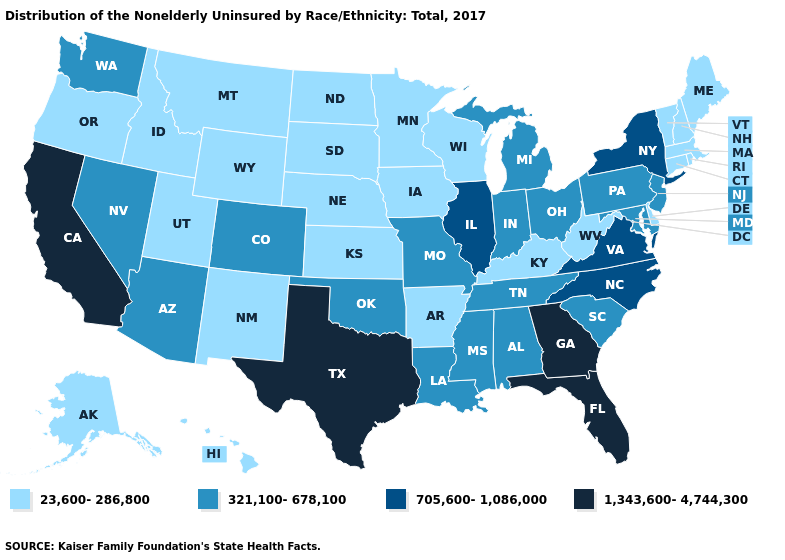What is the value of Louisiana?
Give a very brief answer. 321,100-678,100. Name the states that have a value in the range 705,600-1,086,000?
Answer briefly. Illinois, New York, North Carolina, Virginia. What is the value of Massachusetts?
Write a very short answer. 23,600-286,800. What is the value of Kentucky?
Short answer required. 23,600-286,800. Does Tennessee have a lower value than Georgia?
Quick response, please. Yes. Among the states that border Texas , which have the highest value?
Quick response, please. Louisiana, Oklahoma. Among the states that border Idaho , does Washington have the highest value?
Keep it brief. Yes. What is the value of New Hampshire?
Keep it brief. 23,600-286,800. What is the value of Delaware?
Give a very brief answer. 23,600-286,800. What is the value of Missouri?
Quick response, please. 321,100-678,100. Does Nebraska have a lower value than Maryland?
Give a very brief answer. Yes. Which states hav the highest value in the Northeast?
Quick response, please. New York. Name the states that have a value in the range 705,600-1,086,000?
Answer briefly. Illinois, New York, North Carolina, Virginia. How many symbols are there in the legend?
Keep it brief. 4. Does Wyoming have a lower value than Vermont?
Be succinct. No. 